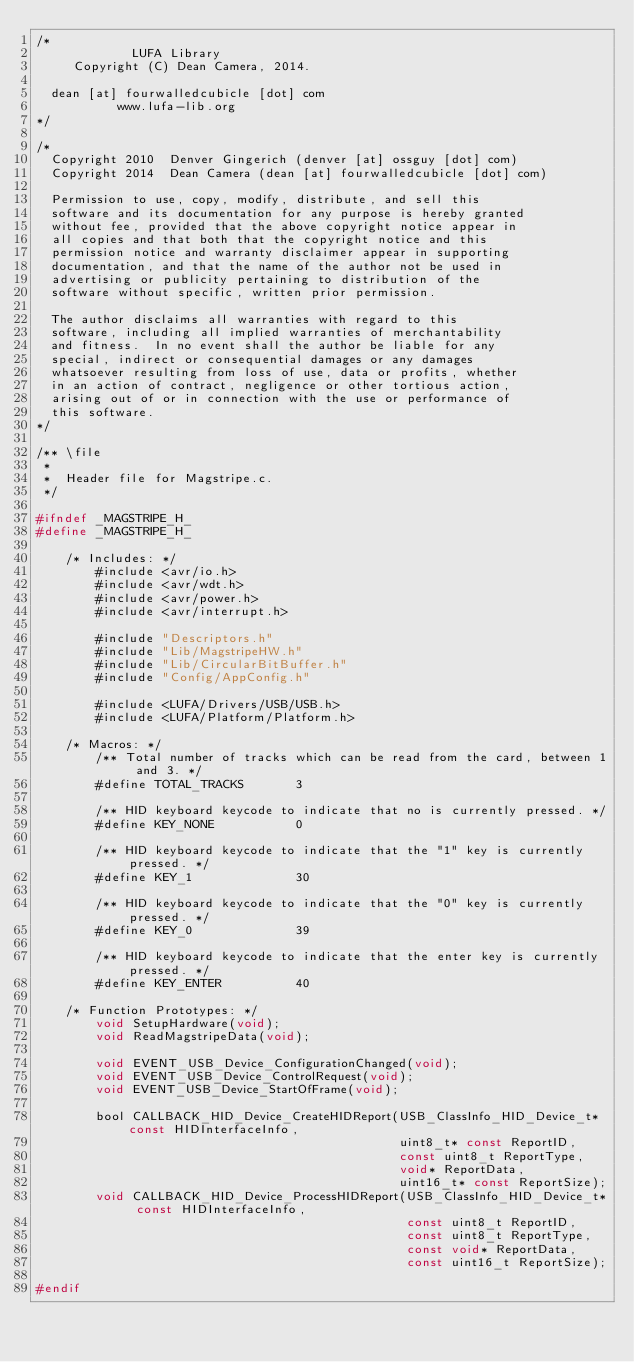Convert code to text. <code><loc_0><loc_0><loc_500><loc_500><_C_>/*
             LUFA Library
     Copyright (C) Dean Camera, 2014.

  dean [at] fourwalledcubicle [dot] com
           www.lufa-lib.org
*/

/*
  Copyright 2010  Denver Gingerich (denver [at] ossguy [dot] com)
  Copyright 2014  Dean Camera (dean [at] fourwalledcubicle [dot] com)

  Permission to use, copy, modify, distribute, and sell this
  software and its documentation for any purpose is hereby granted
  without fee, provided that the above copyright notice appear in
  all copies and that both that the copyright notice and this
  permission notice and warranty disclaimer appear in supporting
  documentation, and that the name of the author not be used in
  advertising or publicity pertaining to distribution of the
  software without specific, written prior permission.

  The author disclaims all warranties with regard to this
  software, including all implied warranties of merchantability
  and fitness.  In no event shall the author be liable for any
  special, indirect or consequential damages or any damages
  whatsoever resulting from loss of use, data or profits, whether
  in an action of contract, negligence or other tortious action,
  arising out of or in connection with the use or performance of
  this software.
*/

/** \file
 *
 *  Header file for Magstripe.c.
 */

#ifndef _MAGSTRIPE_H_
#define _MAGSTRIPE_H_

	/* Includes: */
		#include <avr/io.h>
		#include <avr/wdt.h>
		#include <avr/power.h>
		#include <avr/interrupt.h>

		#include "Descriptors.h"
		#include "Lib/MagstripeHW.h"
		#include "Lib/CircularBitBuffer.h"
		#include "Config/AppConfig.h"

		#include <LUFA/Drivers/USB/USB.h>
		#include <LUFA/Platform/Platform.h>

	/* Macros: */
		/** Total number of tracks which can be read from the card, between 1 and 3. */
		#define TOTAL_TRACKS       3

		/** HID keyboard keycode to indicate that no is currently pressed. */
		#define KEY_NONE           0

		/** HID keyboard keycode to indicate that the "1" key is currently pressed. */
		#define KEY_1              30

		/** HID keyboard keycode to indicate that the "0" key is currently pressed. */
		#define KEY_0              39

		/** HID keyboard keycode to indicate that the enter key is currently pressed. */
		#define KEY_ENTER          40

	/* Function Prototypes: */
		void SetupHardware(void);
		void ReadMagstripeData(void);

		void EVENT_USB_Device_ConfigurationChanged(void);
		void EVENT_USB_Device_ControlRequest(void);
		void EVENT_USB_Device_StartOfFrame(void);

		bool CALLBACK_HID_Device_CreateHIDReport(USB_ClassInfo_HID_Device_t* const HIDInterfaceInfo,
		                                         uint8_t* const ReportID,
		                                         const uint8_t ReportType,
		                                         void* ReportData,
		                                         uint16_t* const ReportSize);
		void CALLBACK_HID_Device_ProcessHIDReport(USB_ClassInfo_HID_Device_t* const HIDInterfaceInfo,
		                                          const uint8_t ReportID,
		                                          const uint8_t ReportType,
		                                          const void* ReportData,
		                                          const uint16_t ReportSize);

#endif

</code> 